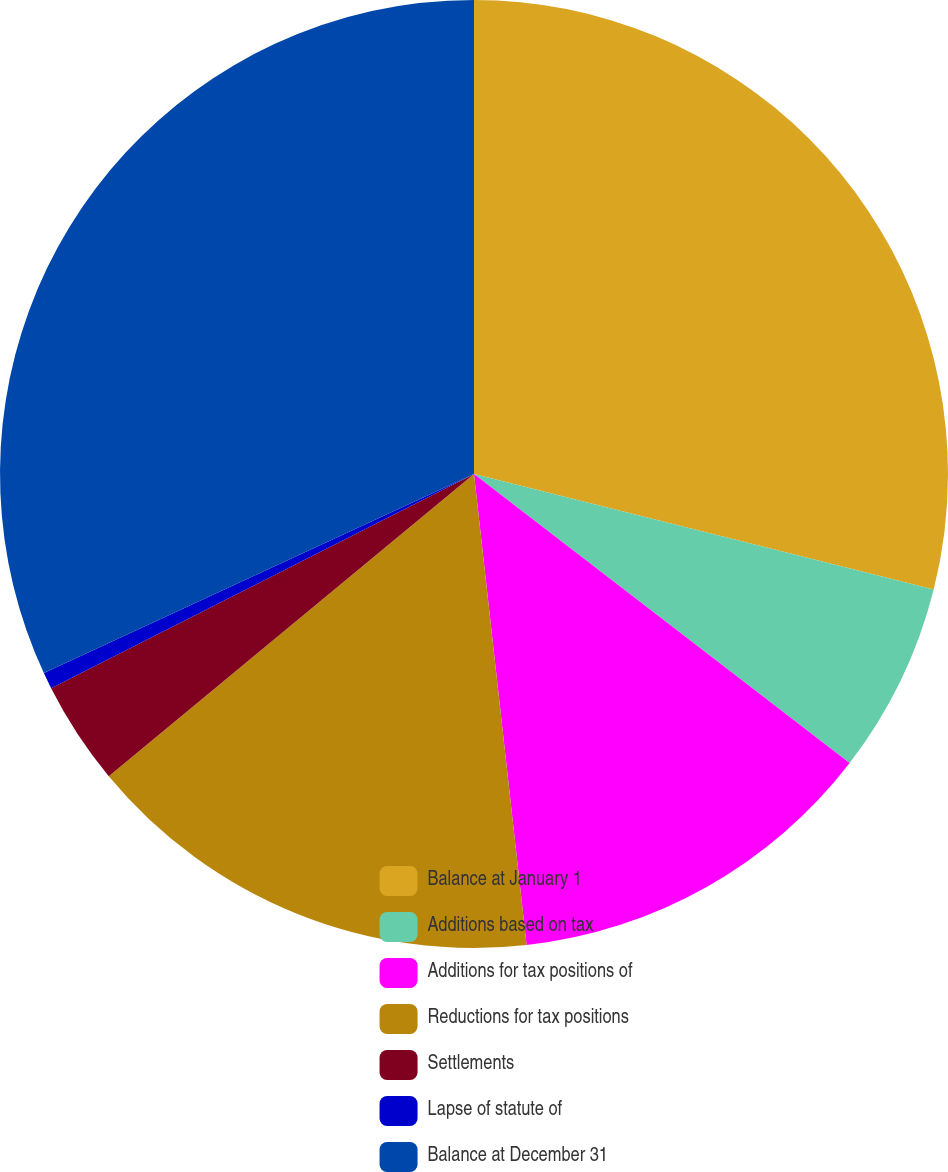Convert chart. <chart><loc_0><loc_0><loc_500><loc_500><pie_chart><fcel>Balance at January 1<fcel>Additions based on tax<fcel>Additions for tax positions of<fcel>Reductions for tax positions<fcel>Settlements<fcel>Lapse of statute of<fcel>Balance at December 31<nl><fcel>28.92%<fcel>6.52%<fcel>12.79%<fcel>15.77%<fcel>3.54%<fcel>0.56%<fcel>31.9%<nl></chart> 